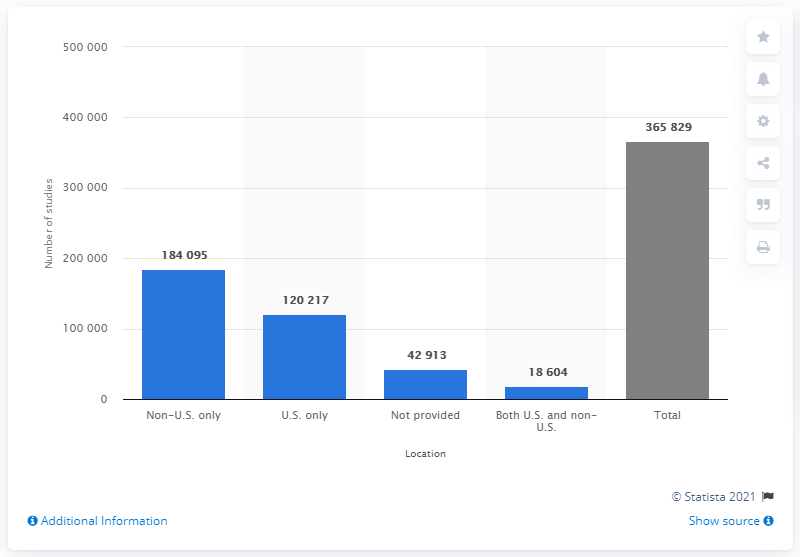Indicate a few pertinent items in this graphic. As of February 2, 2021, there were 120,217 registered clinical studies in the United States. There were 184,095 registered clinical studies conducted outside of the United States. 